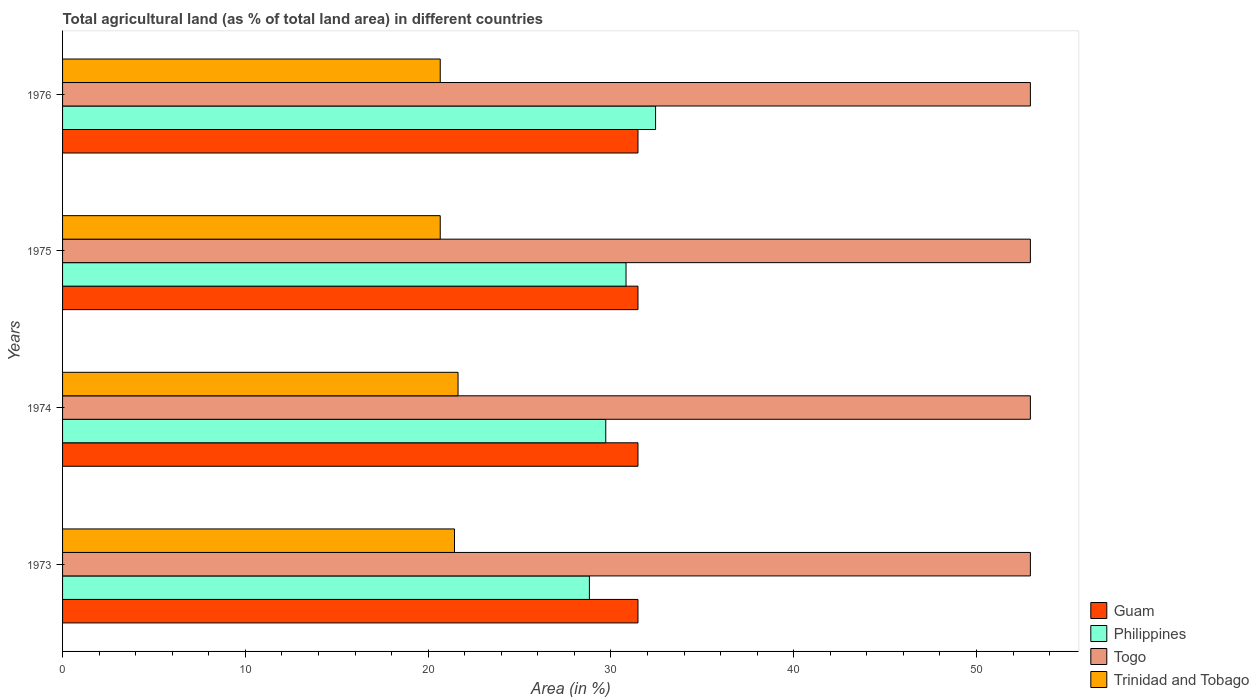How many different coloured bars are there?
Offer a very short reply. 4. Are the number of bars per tick equal to the number of legend labels?
Make the answer very short. Yes. Are the number of bars on each tick of the Y-axis equal?
Your response must be concise. Yes. What is the label of the 3rd group of bars from the top?
Your response must be concise. 1974. In how many cases, is the number of bars for a given year not equal to the number of legend labels?
Your answer should be very brief. 0. What is the percentage of agricultural land in Trinidad and Tobago in 1975?
Offer a terse response. 20.66. Across all years, what is the maximum percentage of agricultural land in Togo?
Ensure brevity in your answer.  52.95. Across all years, what is the minimum percentage of agricultural land in Togo?
Ensure brevity in your answer.  52.95. In which year was the percentage of agricultural land in Trinidad and Tobago maximum?
Offer a terse response. 1974. In which year was the percentage of agricultural land in Philippines minimum?
Make the answer very short. 1973. What is the total percentage of agricultural land in Trinidad and Tobago in the graph?
Give a very brief answer. 84.41. What is the difference between the percentage of agricultural land in Togo in 1973 and that in 1976?
Keep it short and to the point. 0. What is the difference between the percentage of agricultural land in Philippines in 1975 and the percentage of agricultural land in Guam in 1976?
Provide a succinct answer. -0.65. What is the average percentage of agricultural land in Philippines per year?
Provide a short and direct response. 30.45. In the year 1975, what is the difference between the percentage of agricultural land in Togo and percentage of agricultural land in Philippines?
Your response must be concise. 22.12. Is the difference between the percentage of agricultural land in Togo in 1974 and 1975 greater than the difference between the percentage of agricultural land in Philippines in 1974 and 1975?
Ensure brevity in your answer.  Yes. What is the difference between the highest and the lowest percentage of agricultural land in Togo?
Offer a terse response. 0. In how many years, is the percentage of agricultural land in Philippines greater than the average percentage of agricultural land in Philippines taken over all years?
Provide a short and direct response. 2. Is the sum of the percentage of agricultural land in Trinidad and Tobago in 1975 and 1976 greater than the maximum percentage of agricultural land in Guam across all years?
Ensure brevity in your answer.  Yes. What does the 3rd bar from the top in 1973 represents?
Offer a terse response. Philippines. What does the 3rd bar from the bottom in 1976 represents?
Offer a very short reply. Togo. Is it the case that in every year, the sum of the percentage of agricultural land in Philippines and percentage of agricultural land in Togo is greater than the percentage of agricultural land in Guam?
Give a very brief answer. Yes. How many bars are there?
Your response must be concise. 16. Are all the bars in the graph horizontal?
Keep it short and to the point. Yes. What is the difference between two consecutive major ticks on the X-axis?
Ensure brevity in your answer.  10. Are the values on the major ticks of X-axis written in scientific E-notation?
Your response must be concise. No. Does the graph contain any zero values?
Your answer should be very brief. No. How are the legend labels stacked?
Your answer should be very brief. Vertical. What is the title of the graph?
Provide a short and direct response. Total agricultural land (as % of total land area) in different countries. What is the label or title of the X-axis?
Offer a terse response. Area (in %). What is the label or title of the Y-axis?
Provide a short and direct response. Years. What is the Area (in %) of Guam in 1973?
Make the answer very short. 31.48. What is the Area (in %) in Philippines in 1973?
Offer a very short reply. 28.82. What is the Area (in %) of Togo in 1973?
Your response must be concise. 52.95. What is the Area (in %) of Trinidad and Tobago in 1973?
Offer a very short reply. 21.44. What is the Area (in %) of Guam in 1974?
Your response must be concise. 31.48. What is the Area (in %) in Philippines in 1974?
Keep it short and to the point. 29.72. What is the Area (in %) in Togo in 1974?
Give a very brief answer. 52.95. What is the Area (in %) in Trinidad and Tobago in 1974?
Your answer should be very brief. 21.64. What is the Area (in %) in Guam in 1975?
Provide a short and direct response. 31.48. What is the Area (in %) in Philippines in 1975?
Ensure brevity in your answer.  30.83. What is the Area (in %) of Togo in 1975?
Ensure brevity in your answer.  52.95. What is the Area (in %) in Trinidad and Tobago in 1975?
Offer a very short reply. 20.66. What is the Area (in %) of Guam in 1976?
Provide a succinct answer. 31.48. What is the Area (in %) in Philippines in 1976?
Keep it short and to the point. 32.44. What is the Area (in %) in Togo in 1976?
Ensure brevity in your answer.  52.95. What is the Area (in %) of Trinidad and Tobago in 1976?
Your answer should be compact. 20.66. Across all years, what is the maximum Area (in %) of Guam?
Give a very brief answer. 31.48. Across all years, what is the maximum Area (in %) in Philippines?
Offer a very short reply. 32.44. Across all years, what is the maximum Area (in %) of Togo?
Keep it short and to the point. 52.95. Across all years, what is the maximum Area (in %) of Trinidad and Tobago?
Provide a short and direct response. 21.64. Across all years, what is the minimum Area (in %) of Guam?
Keep it short and to the point. 31.48. Across all years, what is the minimum Area (in %) of Philippines?
Keep it short and to the point. 28.82. Across all years, what is the minimum Area (in %) of Togo?
Make the answer very short. 52.95. Across all years, what is the minimum Area (in %) in Trinidad and Tobago?
Ensure brevity in your answer.  20.66. What is the total Area (in %) of Guam in the graph?
Your response must be concise. 125.93. What is the total Area (in %) in Philippines in the graph?
Offer a terse response. 121.82. What is the total Area (in %) in Togo in the graph?
Offer a terse response. 211.8. What is the total Area (in %) in Trinidad and Tobago in the graph?
Your answer should be very brief. 84.41. What is the difference between the Area (in %) of Philippines in 1973 and that in 1974?
Your response must be concise. -0.9. What is the difference between the Area (in %) of Trinidad and Tobago in 1973 and that in 1974?
Give a very brief answer. -0.19. What is the difference between the Area (in %) of Philippines in 1973 and that in 1975?
Provide a short and direct response. -2. What is the difference between the Area (in %) in Trinidad and Tobago in 1973 and that in 1975?
Give a very brief answer. 0.78. What is the difference between the Area (in %) of Philippines in 1973 and that in 1976?
Provide a succinct answer. -3.62. What is the difference between the Area (in %) of Trinidad and Tobago in 1973 and that in 1976?
Give a very brief answer. 0.78. What is the difference between the Area (in %) of Philippines in 1974 and that in 1975?
Offer a terse response. -1.11. What is the difference between the Area (in %) of Togo in 1974 and that in 1975?
Ensure brevity in your answer.  0. What is the difference between the Area (in %) in Trinidad and Tobago in 1974 and that in 1975?
Your answer should be compact. 0.97. What is the difference between the Area (in %) in Philippines in 1974 and that in 1976?
Make the answer very short. -2.73. What is the difference between the Area (in %) in Trinidad and Tobago in 1974 and that in 1976?
Give a very brief answer. 0.97. What is the difference between the Area (in %) in Philippines in 1975 and that in 1976?
Offer a terse response. -1.62. What is the difference between the Area (in %) of Togo in 1975 and that in 1976?
Your response must be concise. 0. What is the difference between the Area (in %) of Trinidad and Tobago in 1975 and that in 1976?
Provide a short and direct response. 0. What is the difference between the Area (in %) of Guam in 1973 and the Area (in %) of Philippines in 1974?
Make the answer very short. 1.76. What is the difference between the Area (in %) in Guam in 1973 and the Area (in %) in Togo in 1974?
Your response must be concise. -21.47. What is the difference between the Area (in %) of Guam in 1973 and the Area (in %) of Trinidad and Tobago in 1974?
Offer a very short reply. 9.84. What is the difference between the Area (in %) of Philippines in 1973 and the Area (in %) of Togo in 1974?
Your response must be concise. -24.13. What is the difference between the Area (in %) in Philippines in 1973 and the Area (in %) in Trinidad and Tobago in 1974?
Ensure brevity in your answer.  7.19. What is the difference between the Area (in %) in Togo in 1973 and the Area (in %) in Trinidad and Tobago in 1974?
Make the answer very short. 31.31. What is the difference between the Area (in %) in Guam in 1973 and the Area (in %) in Philippines in 1975?
Offer a very short reply. 0.65. What is the difference between the Area (in %) in Guam in 1973 and the Area (in %) in Togo in 1975?
Offer a very short reply. -21.47. What is the difference between the Area (in %) in Guam in 1973 and the Area (in %) in Trinidad and Tobago in 1975?
Ensure brevity in your answer.  10.82. What is the difference between the Area (in %) of Philippines in 1973 and the Area (in %) of Togo in 1975?
Give a very brief answer. -24.13. What is the difference between the Area (in %) in Philippines in 1973 and the Area (in %) in Trinidad and Tobago in 1975?
Keep it short and to the point. 8.16. What is the difference between the Area (in %) of Togo in 1973 and the Area (in %) of Trinidad and Tobago in 1975?
Keep it short and to the point. 32.29. What is the difference between the Area (in %) of Guam in 1973 and the Area (in %) of Philippines in 1976?
Your response must be concise. -0.96. What is the difference between the Area (in %) of Guam in 1973 and the Area (in %) of Togo in 1976?
Make the answer very short. -21.47. What is the difference between the Area (in %) in Guam in 1973 and the Area (in %) in Trinidad and Tobago in 1976?
Offer a terse response. 10.82. What is the difference between the Area (in %) of Philippines in 1973 and the Area (in %) of Togo in 1976?
Provide a short and direct response. -24.13. What is the difference between the Area (in %) in Philippines in 1973 and the Area (in %) in Trinidad and Tobago in 1976?
Your answer should be very brief. 8.16. What is the difference between the Area (in %) of Togo in 1973 and the Area (in %) of Trinidad and Tobago in 1976?
Offer a very short reply. 32.29. What is the difference between the Area (in %) in Guam in 1974 and the Area (in %) in Philippines in 1975?
Make the answer very short. 0.65. What is the difference between the Area (in %) in Guam in 1974 and the Area (in %) in Togo in 1975?
Ensure brevity in your answer.  -21.47. What is the difference between the Area (in %) of Guam in 1974 and the Area (in %) of Trinidad and Tobago in 1975?
Offer a terse response. 10.82. What is the difference between the Area (in %) of Philippines in 1974 and the Area (in %) of Togo in 1975?
Provide a short and direct response. -23.23. What is the difference between the Area (in %) of Philippines in 1974 and the Area (in %) of Trinidad and Tobago in 1975?
Make the answer very short. 9.06. What is the difference between the Area (in %) of Togo in 1974 and the Area (in %) of Trinidad and Tobago in 1975?
Provide a short and direct response. 32.29. What is the difference between the Area (in %) of Guam in 1974 and the Area (in %) of Philippines in 1976?
Your response must be concise. -0.96. What is the difference between the Area (in %) of Guam in 1974 and the Area (in %) of Togo in 1976?
Offer a terse response. -21.47. What is the difference between the Area (in %) of Guam in 1974 and the Area (in %) of Trinidad and Tobago in 1976?
Ensure brevity in your answer.  10.82. What is the difference between the Area (in %) of Philippines in 1974 and the Area (in %) of Togo in 1976?
Provide a short and direct response. -23.23. What is the difference between the Area (in %) of Philippines in 1974 and the Area (in %) of Trinidad and Tobago in 1976?
Offer a terse response. 9.06. What is the difference between the Area (in %) of Togo in 1974 and the Area (in %) of Trinidad and Tobago in 1976?
Offer a terse response. 32.29. What is the difference between the Area (in %) in Guam in 1975 and the Area (in %) in Philippines in 1976?
Provide a succinct answer. -0.96. What is the difference between the Area (in %) of Guam in 1975 and the Area (in %) of Togo in 1976?
Give a very brief answer. -21.47. What is the difference between the Area (in %) in Guam in 1975 and the Area (in %) in Trinidad and Tobago in 1976?
Offer a terse response. 10.82. What is the difference between the Area (in %) in Philippines in 1975 and the Area (in %) in Togo in 1976?
Your answer should be very brief. -22.12. What is the difference between the Area (in %) in Philippines in 1975 and the Area (in %) in Trinidad and Tobago in 1976?
Provide a succinct answer. 10.17. What is the difference between the Area (in %) of Togo in 1975 and the Area (in %) of Trinidad and Tobago in 1976?
Provide a short and direct response. 32.29. What is the average Area (in %) of Guam per year?
Your response must be concise. 31.48. What is the average Area (in %) of Philippines per year?
Your answer should be compact. 30.45. What is the average Area (in %) in Togo per year?
Give a very brief answer. 52.95. What is the average Area (in %) of Trinidad and Tobago per year?
Your response must be concise. 21.1. In the year 1973, what is the difference between the Area (in %) in Guam and Area (in %) in Philippines?
Your answer should be compact. 2.66. In the year 1973, what is the difference between the Area (in %) in Guam and Area (in %) in Togo?
Ensure brevity in your answer.  -21.47. In the year 1973, what is the difference between the Area (in %) of Guam and Area (in %) of Trinidad and Tobago?
Make the answer very short. 10.04. In the year 1973, what is the difference between the Area (in %) in Philippines and Area (in %) in Togo?
Provide a short and direct response. -24.13. In the year 1973, what is the difference between the Area (in %) of Philippines and Area (in %) of Trinidad and Tobago?
Provide a succinct answer. 7.38. In the year 1973, what is the difference between the Area (in %) of Togo and Area (in %) of Trinidad and Tobago?
Give a very brief answer. 31.51. In the year 1974, what is the difference between the Area (in %) of Guam and Area (in %) of Philippines?
Provide a succinct answer. 1.76. In the year 1974, what is the difference between the Area (in %) of Guam and Area (in %) of Togo?
Keep it short and to the point. -21.47. In the year 1974, what is the difference between the Area (in %) in Guam and Area (in %) in Trinidad and Tobago?
Offer a terse response. 9.84. In the year 1974, what is the difference between the Area (in %) in Philippines and Area (in %) in Togo?
Your answer should be compact. -23.23. In the year 1974, what is the difference between the Area (in %) in Philippines and Area (in %) in Trinidad and Tobago?
Offer a terse response. 8.08. In the year 1974, what is the difference between the Area (in %) in Togo and Area (in %) in Trinidad and Tobago?
Provide a succinct answer. 31.31. In the year 1975, what is the difference between the Area (in %) of Guam and Area (in %) of Philippines?
Keep it short and to the point. 0.65. In the year 1975, what is the difference between the Area (in %) in Guam and Area (in %) in Togo?
Offer a very short reply. -21.47. In the year 1975, what is the difference between the Area (in %) in Guam and Area (in %) in Trinidad and Tobago?
Offer a very short reply. 10.82. In the year 1975, what is the difference between the Area (in %) in Philippines and Area (in %) in Togo?
Your answer should be very brief. -22.12. In the year 1975, what is the difference between the Area (in %) in Philippines and Area (in %) in Trinidad and Tobago?
Your answer should be compact. 10.17. In the year 1975, what is the difference between the Area (in %) of Togo and Area (in %) of Trinidad and Tobago?
Keep it short and to the point. 32.29. In the year 1976, what is the difference between the Area (in %) in Guam and Area (in %) in Philippines?
Offer a terse response. -0.96. In the year 1976, what is the difference between the Area (in %) in Guam and Area (in %) in Togo?
Your response must be concise. -21.47. In the year 1976, what is the difference between the Area (in %) of Guam and Area (in %) of Trinidad and Tobago?
Your answer should be compact. 10.82. In the year 1976, what is the difference between the Area (in %) of Philippines and Area (in %) of Togo?
Offer a terse response. -20.51. In the year 1976, what is the difference between the Area (in %) of Philippines and Area (in %) of Trinidad and Tobago?
Give a very brief answer. 11.78. In the year 1976, what is the difference between the Area (in %) of Togo and Area (in %) of Trinidad and Tobago?
Your response must be concise. 32.29. What is the ratio of the Area (in %) of Philippines in 1973 to that in 1974?
Your answer should be very brief. 0.97. What is the ratio of the Area (in %) in Togo in 1973 to that in 1974?
Provide a succinct answer. 1. What is the ratio of the Area (in %) in Philippines in 1973 to that in 1975?
Ensure brevity in your answer.  0.94. What is the ratio of the Area (in %) of Togo in 1973 to that in 1975?
Offer a very short reply. 1. What is the ratio of the Area (in %) in Trinidad and Tobago in 1973 to that in 1975?
Your response must be concise. 1.04. What is the ratio of the Area (in %) of Guam in 1973 to that in 1976?
Keep it short and to the point. 1. What is the ratio of the Area (in %) of Philippines in 1973 to that in 1976?
Your answer should be compact. 0.89. What is the ratio of the Area (in %) of Trinidad and Tobago in 1973 to that in 1976?
Provide a short and direct response. 1.04. What is the ratio of the Area (in %) in Guam in 1974 to that in 1975?
Your response must be concise. 1. What is the ratio of the Area (in %) of Trinidad and Tobago in 1974 to that in 1975?
Keep it short and to the point. 1.05. What is the ratio of the Area (in %) of Philippines in 1974 to that in 1976?
Provide a short and direct response. 0.92. What is the ratio of the Area (in %) in Trinidad and Tobago in 1974 to that in 1976?
Provide a short and direct response. 1.05. What is the ratio of the Area (in %) of Philippines in 1975 to that in 1976?
Offer a very short reply. 0.95. What is the difference between the highest and the second highest Area (in %) in Guam?
Provide a succinct answer. 0. What is the difference between the highest and the second highest Area (in %) of Philippines?
Your answer should be compact. 1.62. What is the difference between the highest and the second highest Area (in %) of Trinidad and Tobago?
Your answer should be very brief. 0.19. What is the difference between the highest and the lowest Area (in %) in Guam?
Provide a short and direct response. 0. What is the difference between the highest and the lowest Area (in %) of Philippines?
Make the answer very short. 3.62. What is the difference between the highest and the lowest Area (in %) in Trinidad and Tobago?
Offer a terse response. 0.97. 